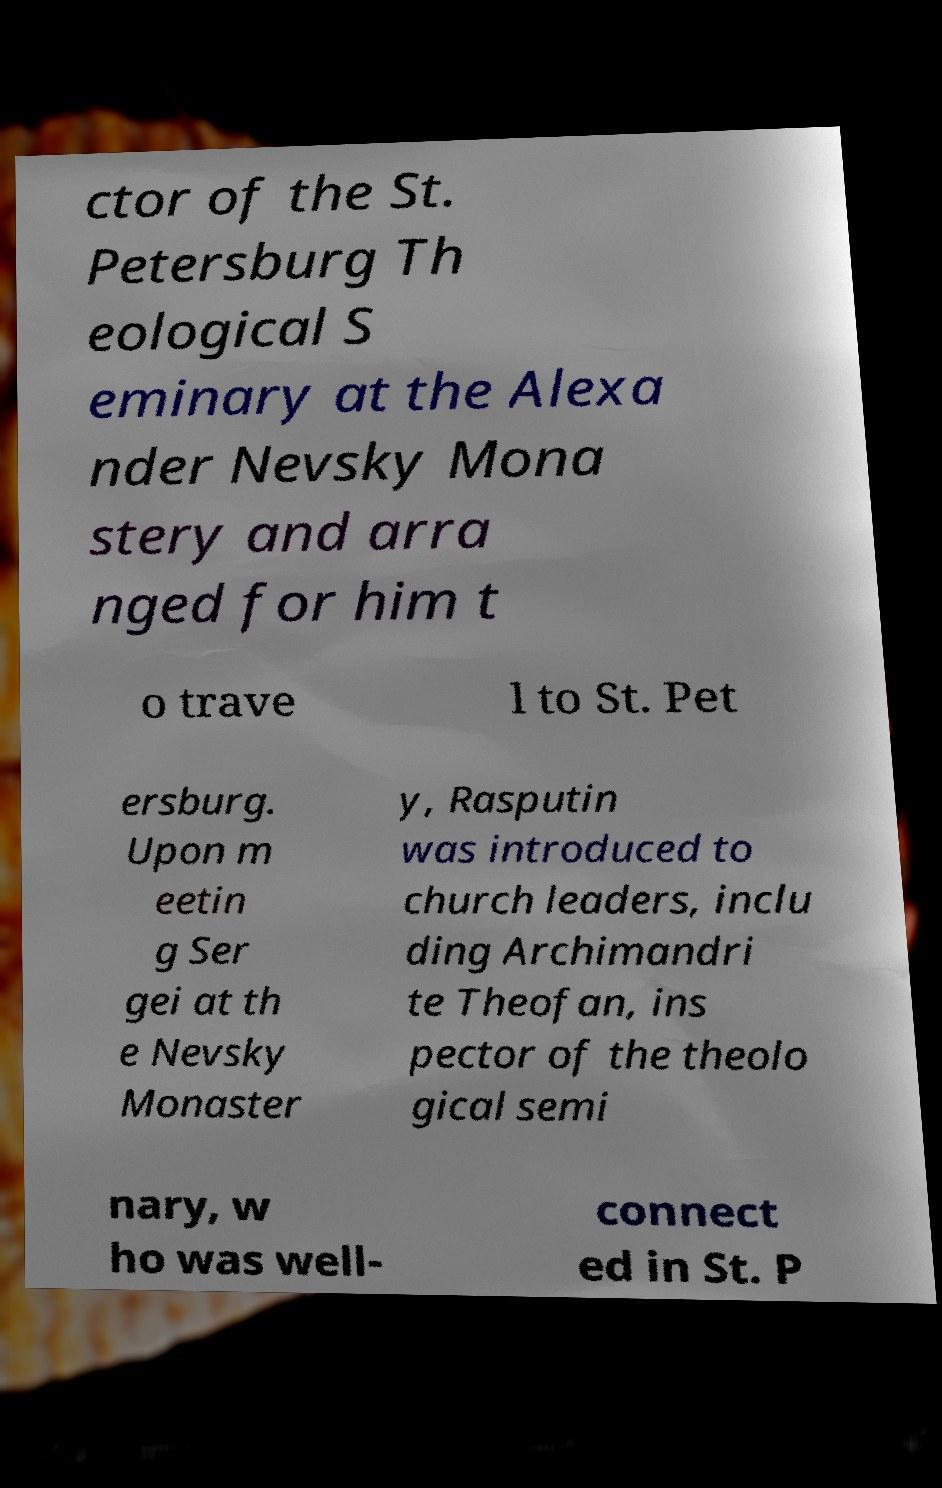What messages or text are displayed in this image? I need them in a readable, typed format. ctor of the St. Petersburg Th eological S eminary at the Alexa nder Nevsky Mona stery and arra nged for him t o trave l to St. Pet ersburg. Upon m eetin g Ser gei at th e Nevsky Monaster y, Rasputin was introduced to church leaders, inclu ding Archimandri te Theofan, ins pector of the theolo gical semi nary, w ho was well- connect ed in St. P 